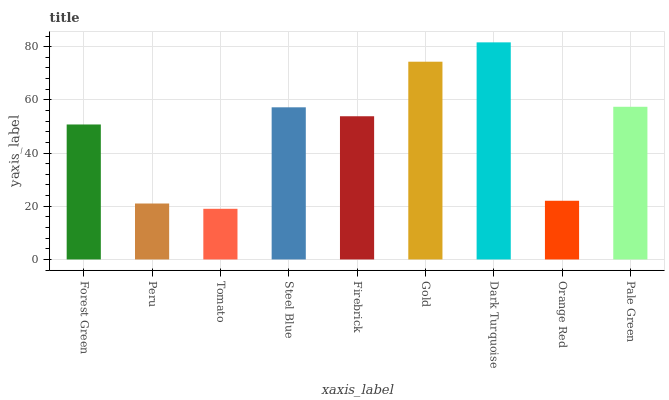Is Tomato the minimum?
Answer yes or no. Yes. Is Dark Turquoise the maximum?
Answer yes or no. Yes. Is Peru the minimum?
Answer yes or no. No. Is Peru the maximum?
Answer yes or no. No. Is Forest Green greater than Peru?
Answer yes or no. Yes. Is Peru less than Forest Green?
Answer yes or no. Yes. Is Peru greater than Forest Green?
Answer yes or no. No. Is Forest Green less than Peru?
Answer yes or no. No. Is Firebrick the high median?
Answer yes or no. Yes. Is Firebrick the low median?
Answer yes or no. Yes. Is Dark Turquoise the high median?
Answer yes or no. No. Is Forest Green the low median?
Answer yes or no. No. 